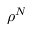Convert formula to latex. <formula><loc_0><loc_0><loc_500><loc_500>\rho ^ { N }</formula> 